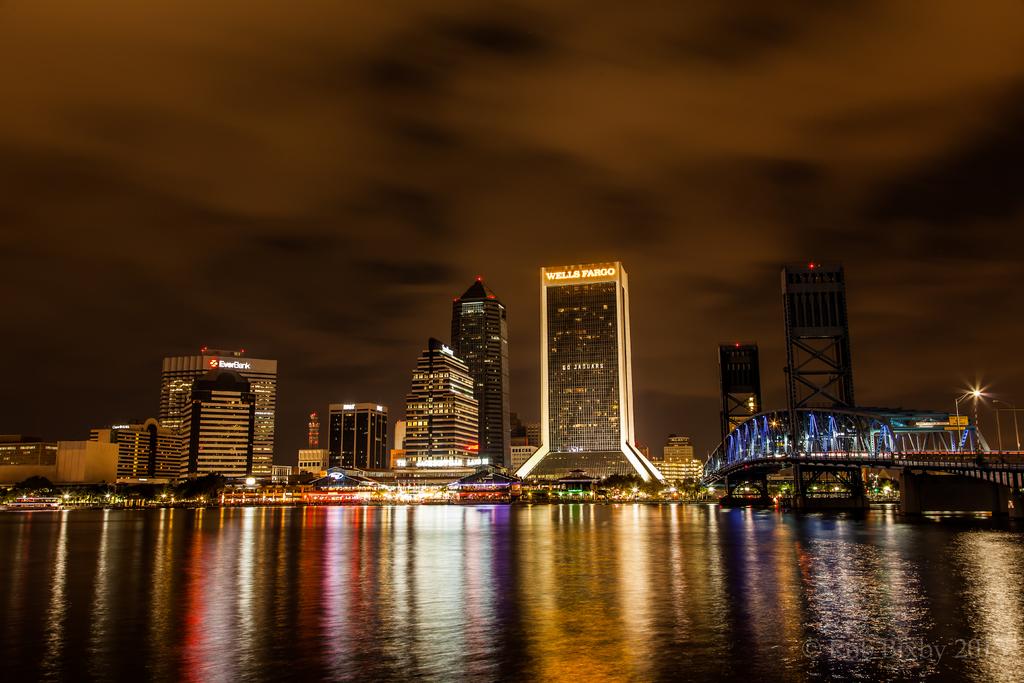What building is in the distance?
Give a very brief answer. Wells fargo. Which bank is on the left?
Ensure brevity in your answer.  Everbank. 